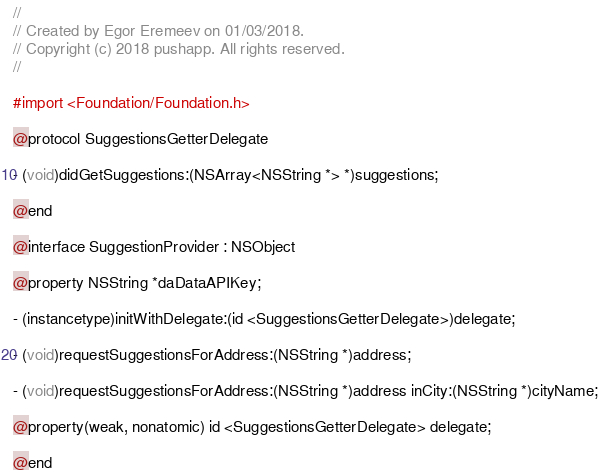<code> <loc_0><loc_0><loc_500><loc_500><_C_>//
// Created by Egor Eremeev on 01/03/2018.
// Copyright (c) 2018 pushapp. All rights reserved.
//

#import <Foundation/Foundation.h>

@protocol SuggestionsGetterDelegate

- (void)didGetSuggestions:(NSArray<NSString *> *)suggestions;

@end

@interface SuggestionProvider : NSObject

@property NSString *daDataAPIKey;

- (instancetype)initWithDelegate:(id <SuggestionsGetterDelegate>)delegate;

- (void)requestSuggestionsForAddress:(NSString *)address;

- (void)requestSuggestionsForAddress:(NSString *)address inCity:(NSString *)cityName;

@property(weak, nonatomic) id <SuggestionsGetterDelegate> delegate;

@end</code> 